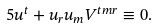<formula> <loc_0><loc_0><loc_500><loc_500>5 u ^ { t } + u _ { r } u _ { m } V ^ { t m r } \equiv 0 { . }</formula> 